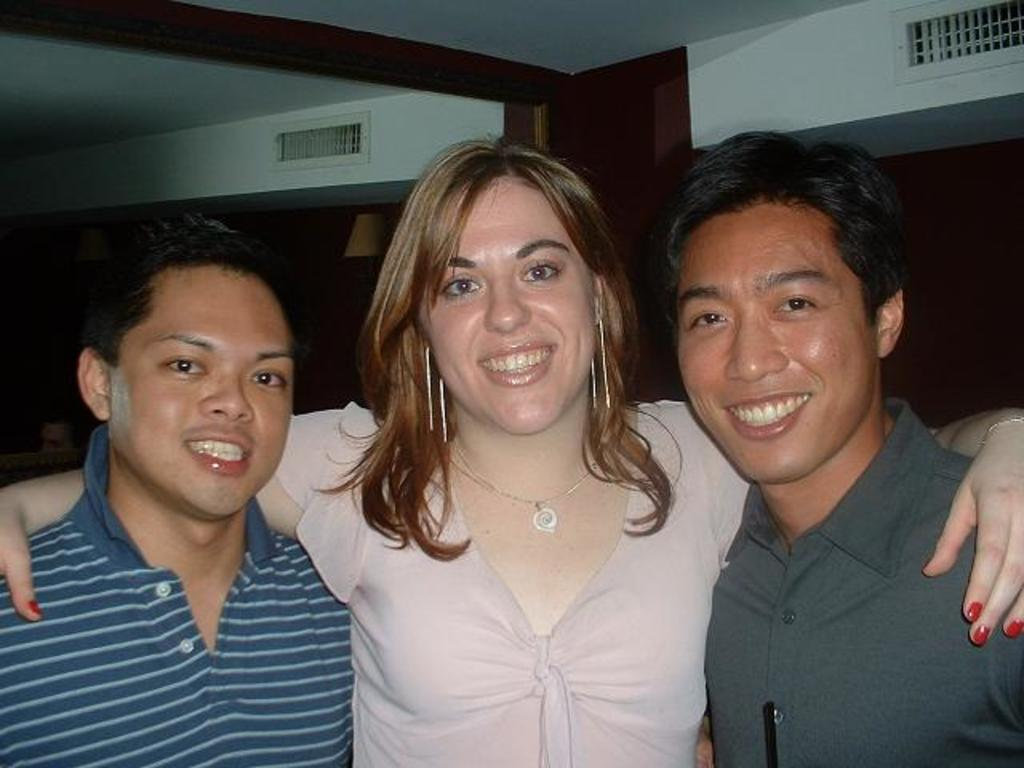How many people are present in the image? There are three people in the image. What expressions do the people have on their faces? The people are wearing smiles on their faces. What can be seen in the background of the image? There are lamps and a wall in the background of the image. What is the weight of the belief system held by the people in the image? There is no indication of any belief system in the image, so it cannot be determined. 